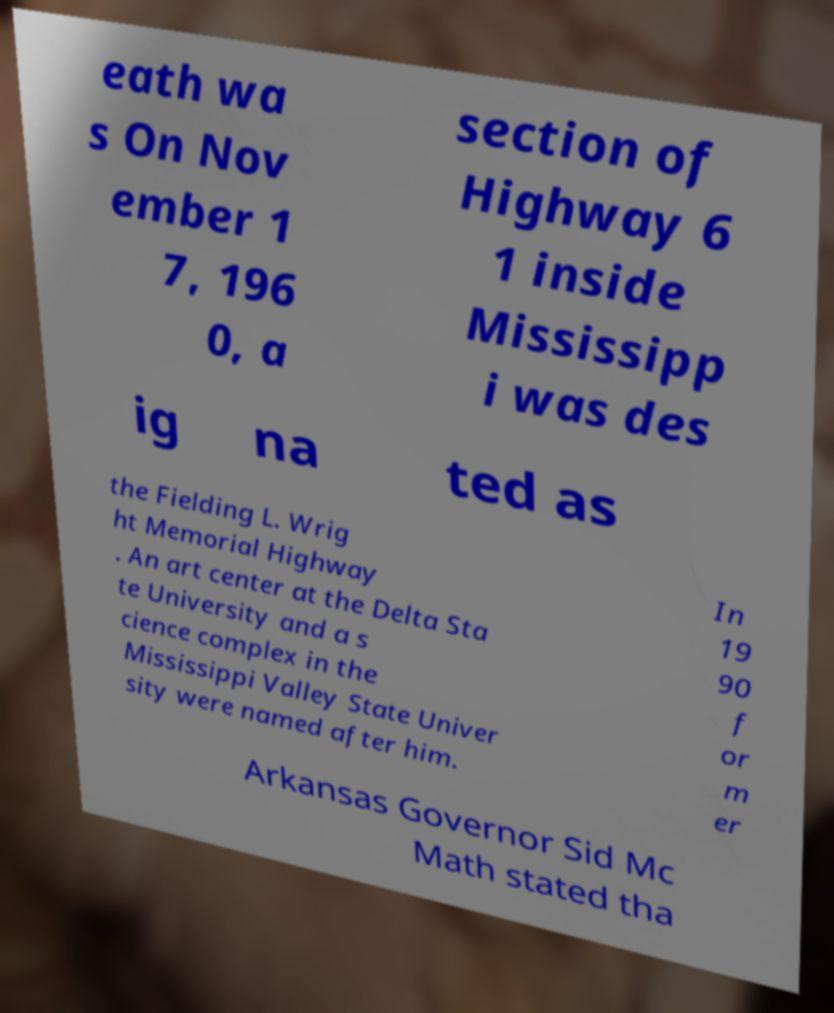I need the written content from this picture converted into text. Can you do that? eath wa s On Nov ember 1 7, 196 0, a section of Highway 6 1 inside Mississipp i was des ig na ted as the Fielding L. Wrig ht Memorial Highway . An art center at the Delta Sta te University and a s cience complex in the Mississippi Valley State Univer sity were named after him. In 19 90 f or m er Arkansas Governor Sid Mc Math stated tha 